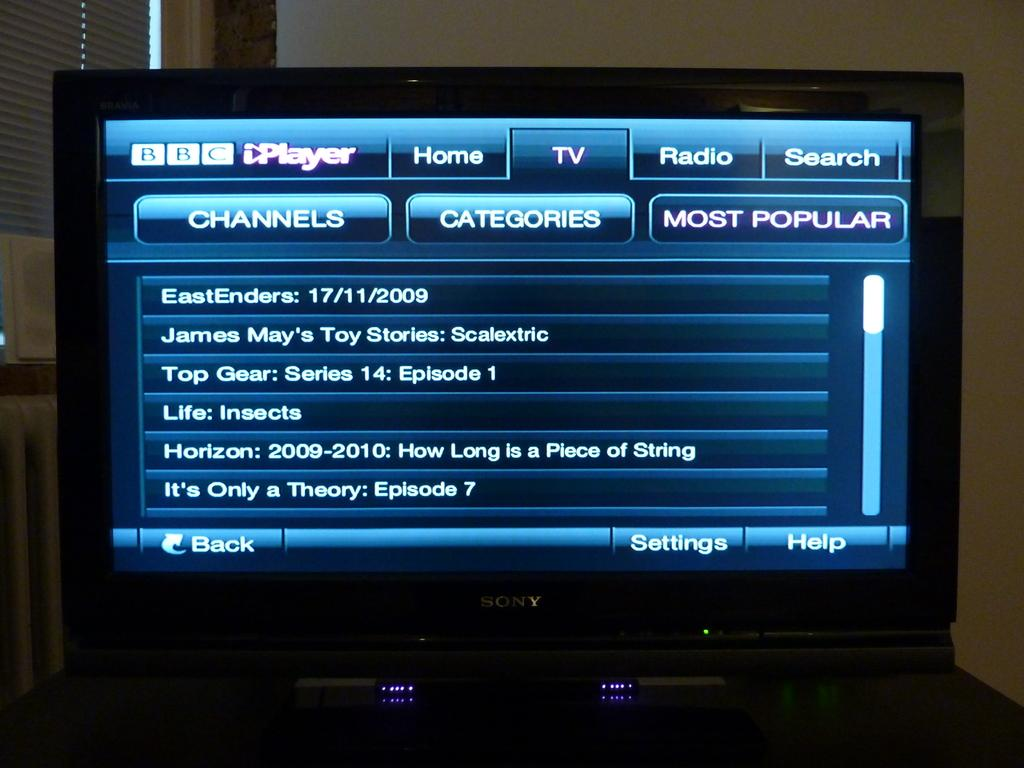What is the main object in the image? There is a screen in the image. What can be seen on the screen? The screen displays some information. What can be seen behind the screen in the image? There is a wall in the background of the image. How does the sister interact with the screen in the image? There is no mention of a sister in the image, so we cannot answer this question. 